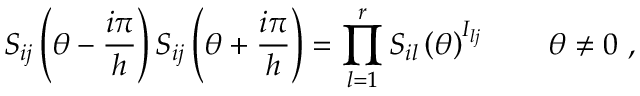Convert formula to latex. <formula><loc_0><loc_0><loc_500><loc_500>S _ { i j } \left ( \theta - \frac { i \pi } { h } \right ) S _ { i j } \left ( \theta + \frac { i \pi } { h } \right ) = \prod _ { l = 1 } ^ { r } S _ { i l } \left ( \theta \right ) ^ { I _ { l j } } \quad \theta \neq 0 \, ,</formula> 